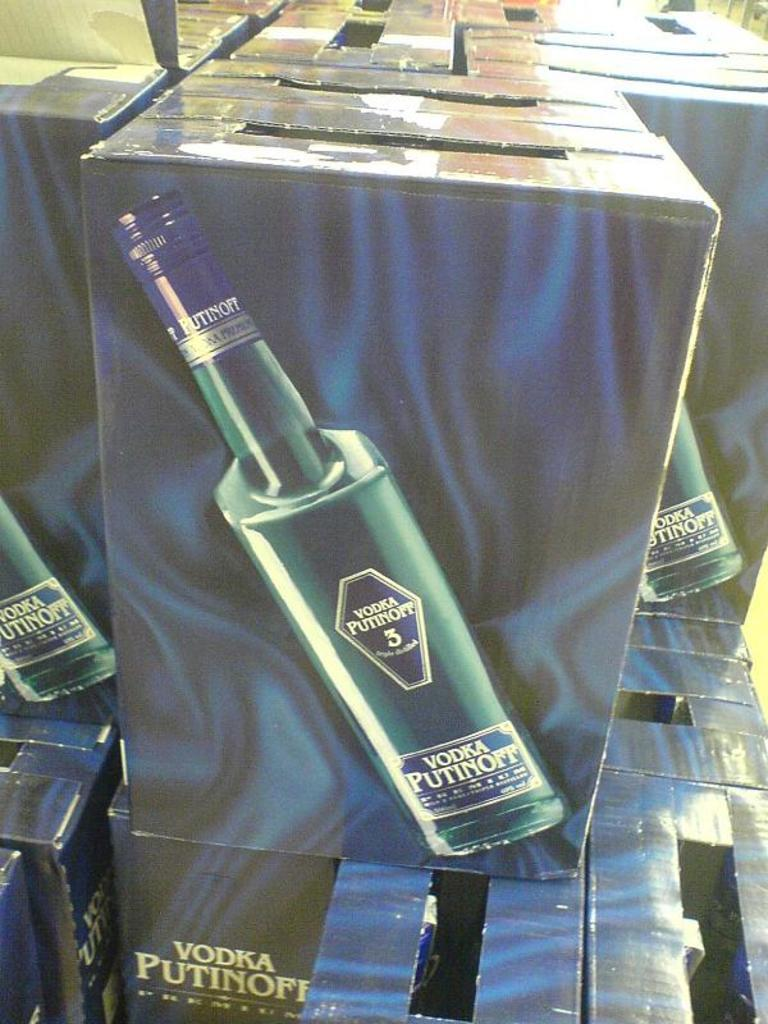<image>
Share a concise interpretation of the image provided. Many boxes of Vodka Putinoff are stacked on each other. 